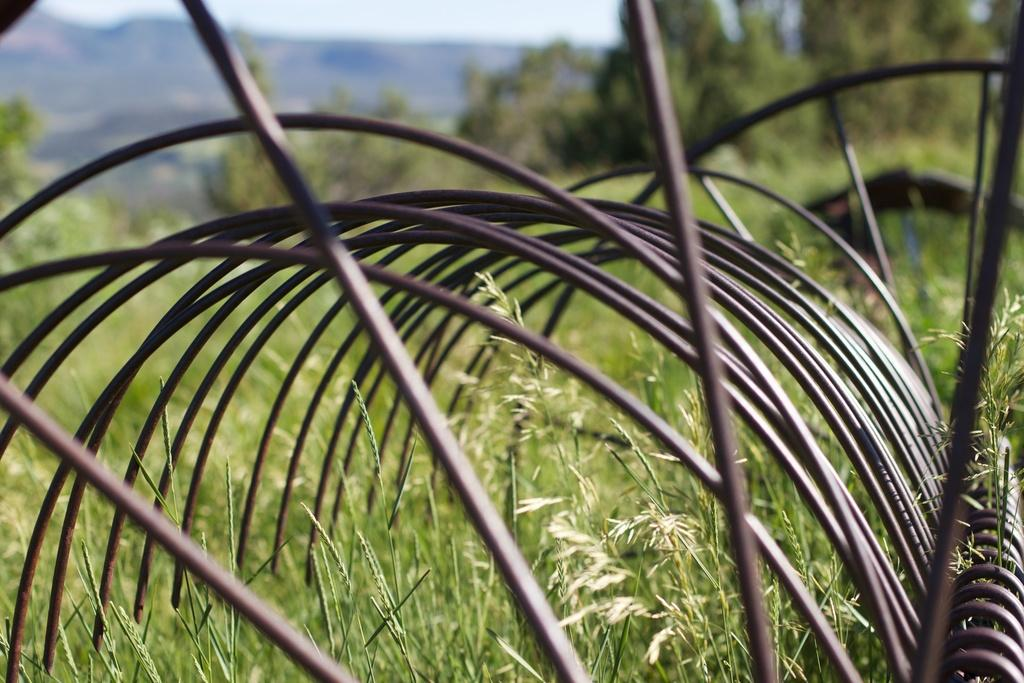What type of vegetation is at the bottom of the image? There is grass at the bottom of the image. What objects can be seen on the right side of the image? There are iron rods on the right side of the image. What can be seen in the background of the image? There are trees and a hill visible in the background of the image. What type of board is being used in the image? There is no board present in the image; it features grass, iron rods, trees, and a hill. 